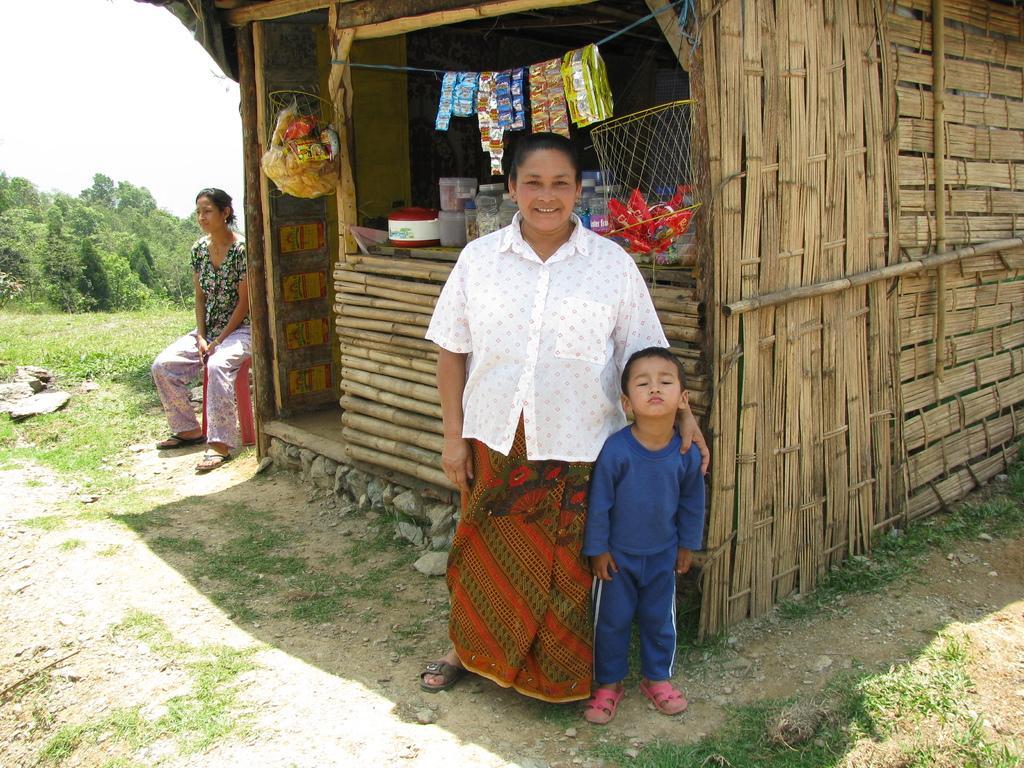Describe this image in one or two sentences. In this image I can see a woman wearing white, orange and green colored dress and a child wearing blue colored dress are standing. In the background I can see a shed which is made up of wood, few objects hanged to the rope, a woman sitting on the stool, few trees and the sky. 